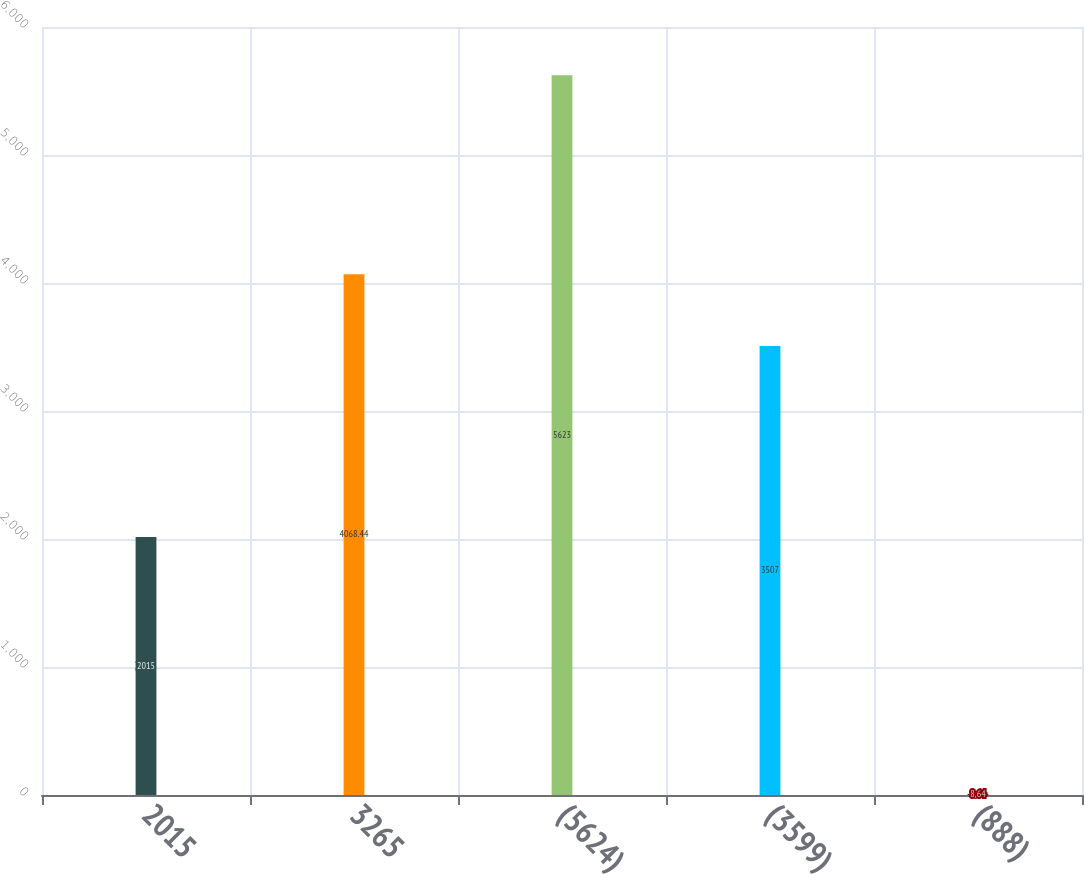Convert chart to OTSL. <chart><loc_0><loc_0><loc_500><loc_500><bar_chart><fcel>2015<fcel>3265<fcel>(5624)<fcel>(3599)<fcel>(888)<nl><fcel>2015<fcel>4068.44<fcel>5623<fcel>3507<fcel>8.64<nl></chart> 